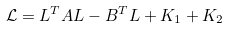Convert formula to latex. <formula><loc_0><loc_0><loc_500><loc_500>\mathcal { L } = L ^ { T } A L - B ^ { T } L + K _ { 1 } + K _ { 2 }</formula> 